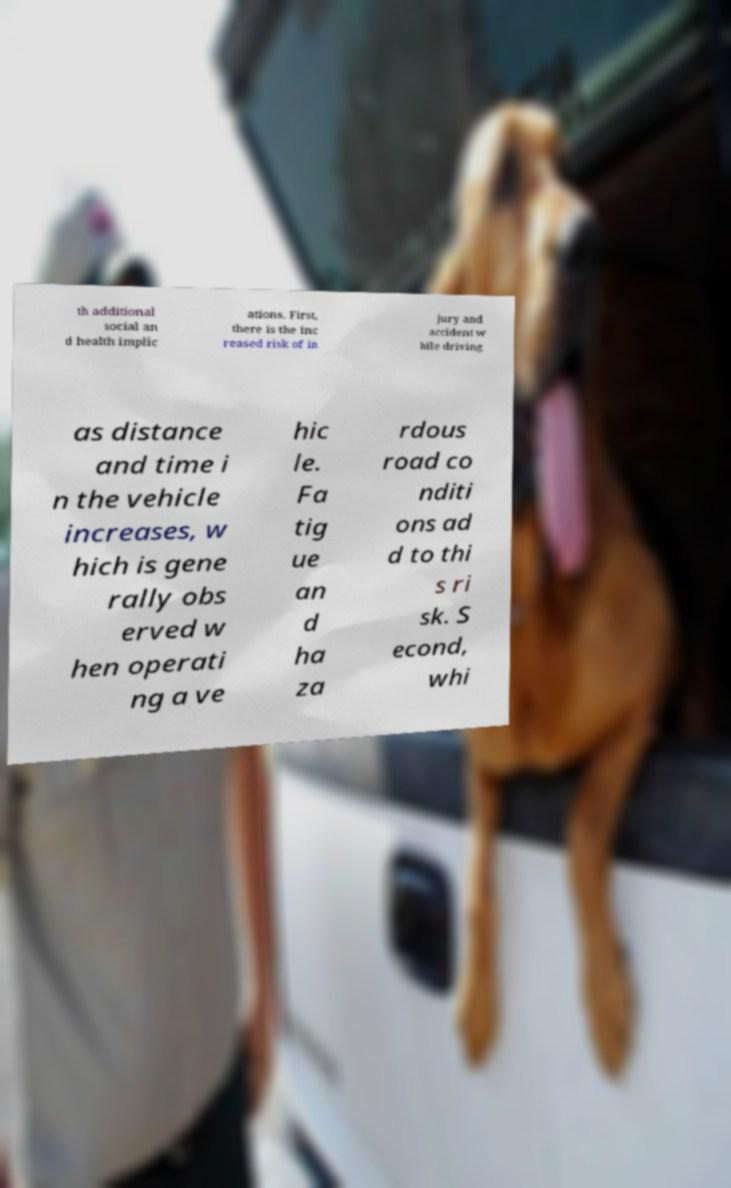Can you accurately transcribe the text from the provided image for me? th additional social an d health implic ations. First, there is the inc reased risk of in jury and accident w hile driving as distance and time i n the vehicle increases, w hich is gene rally obs erved w hen operati ng a ve hic le. Fa tig ue an d ha za rdous road co nditi ons ad d to thi s ri sk. S econd, whi 